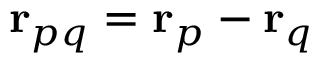<formula> <loc_0><loc_0><loc_500><loc_500>r _ { p q } = r _ { p } - r _ { q }</formula> 